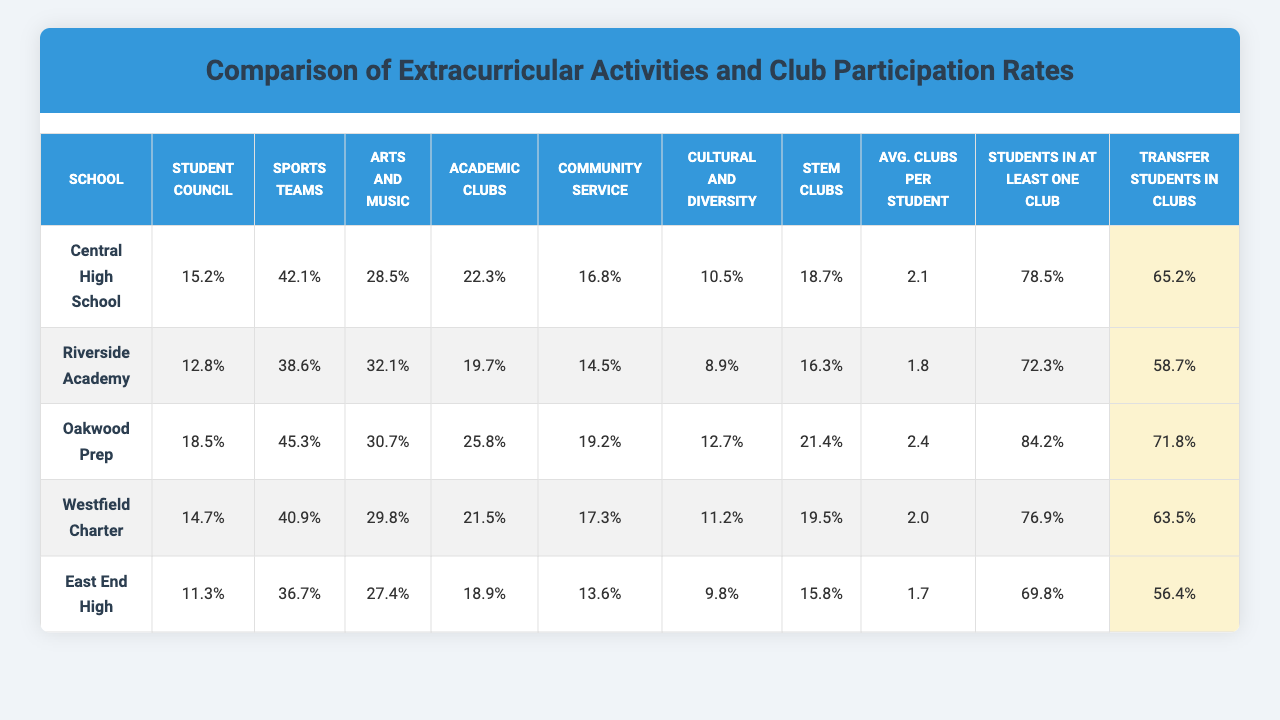What is the participation rate in the Student Council for East End High? According to the table, the participation rate in the Student Council for East End High is 11.3%.
Answer: 11.3% Which school has the highest participation rate in Sports Teams? The table shows that Oakwood Prep has the highest participation rate in Sports Teams at 45.3%.
Answer: 45.3% What is the average participation rate of Cultural and Diversity Clubs across all schools? To find the average, add the participation rates of Cultural and Diversity Clubs for all schools: (10.5 + 8.9 + 12.7 + 11.2 + 9.8) = 53.1, then divide by 5. The average is 53.1 / 5 = 10.62%.
Answer: 10.62% Is the percentage of transfer students involved in clubs greater than the percentage of all students involved in at least one club for Riverside Academy? For Riverside Academy, the percentage of students in at least one club is 72.3% and the percentage of transfer students in clubs is 58.7%. Since 58.7% is less than 72.3%, the statement is false.
Answer: No What is the difference in participation rates between Arts and Music Clubs and Academic Clubs for Central High School? The participation rate for Arts and Music Clubs at Central High School is 28.5%, and for Academic Clubs, it is 22.3%. The difference is 28.5 - 22.3 = 6.2%.
Answer: 6.2% Which school has the lowest average number of clubs per student? The average number of clubs per student for each school is listed, and East End High has the lowest at 1.7.
Answer: 1.7 How does the percentage of transfer students in clubs at Westfield Charter compare to the average percentage of transfer students across all schools? The percentage of transfer students in clubs at Westfield Charter is 63.5%. The average for all schools is calculated as (65.2 + 58.7 + 71.8 + 63.5 + 56.4) / 5 = 63.12%. Since 63.5% is higher than 63.12%, the comparison shows Westfield Charter is above average.
Answer: Above average What is the total participation rate in Community Service Clubs for all schools combined? Add the participation rates for Community Service Clubs: (16.8 + 14.5 + 19.2 + 17.3 + 13.6) = 81.4%.
Answer: 81.4% Does Riverside Academy have a higher rate of participation in Cultural and Diversity Clubs than East End High? Riverside Academy has a participation rate of 8.9% and East End High has 9.8%. Since 8.9% is less than 9.8%, the statement is false.
Answer: No Which school has the largest disparity between the percentage of students in at least one club and the percentage of transfer students in clubs? First, calculate the difference for each school: Central High: 78.5 - 65.2 = 13.3, Riverside Academy: 72.3 - 58.7 = 13.6, Oakwood Prep: 84.2 - 71.8 = 12.4, Westfield Charter: 76.9 - 63.5 = 13.4, East End High: 69.8 - 56.4 = 13.4. The largest disparity is with Riverside Academy at 13.6%.
Answer: Riverside Academy 